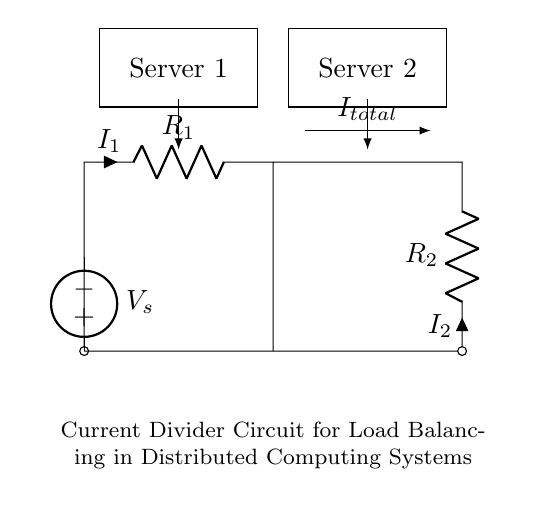What are the components in the circuit? The circuit includes two resistors, R1 and R2, and a voltage source, Vs.
Answer: Resistors and voltage source What is the total current entering the circuit? The total current, I_total, is represented as the sum of currents I1 and I2 flowing through R1 and R2, respectively, as per Kirchhoff's current law.
Answer: I_total What is the function of the voltage source in the circuit? The voltage source, Vs, provides the electrical potential needed to drive the current through the resistors and maintain the circuit's operation.
Answer: Supply voltage What is the relationship between I1, I2, and I_total? In a current divider, the total current is divided among the branches according to the resistance values; specifically, I1 is proportional to 1/R1 and I2 is proportional to 1/R2. This can be stated mathematically as I_total = I1 + I2.
Answer: I_total = I1 + I2 What principle is used in this circuit to balance loads? The current divider principle is used, where the total current is divided inversely by the resistances, ensuring balanced load across the servers.
Answer: Current divider principle How does changing R1 affect I1? According to the current divider formula, increasing R1 will decrease I1 since a higher resistance results in lesser current flow through that path in comparison to R2.
Answer: Decreases I1 